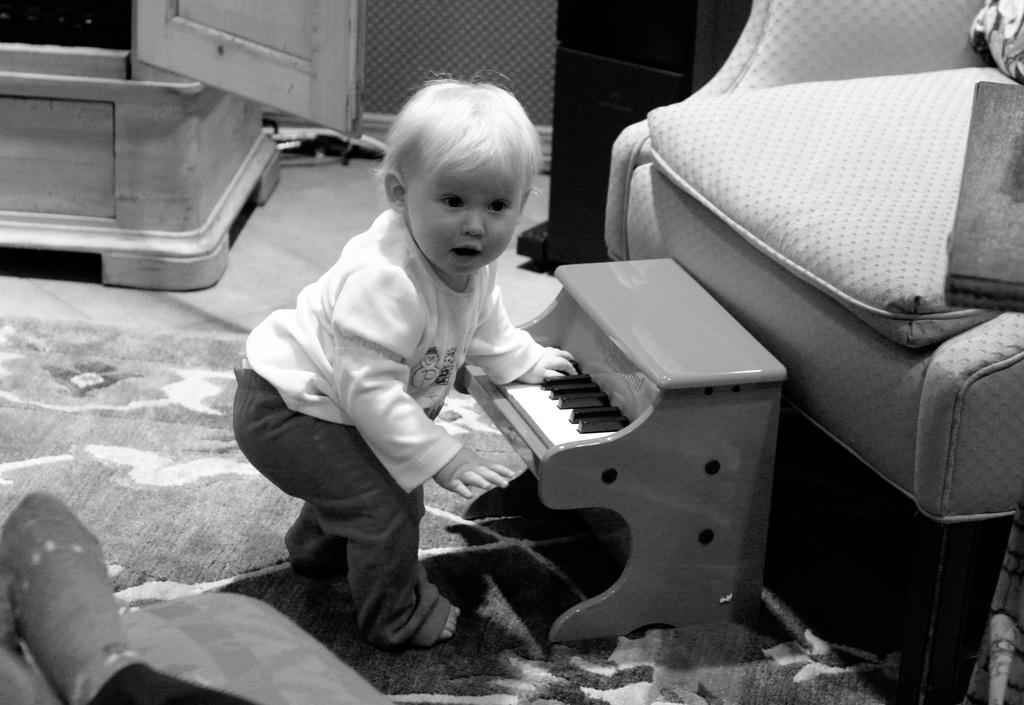What is the main subject of the image? There is a baby in the image. What is the baby doing in the image? The baby is playing a piano. What piece of furniture is on the right side of the image? There is a sofa on the right side of the image. How many balls are visible on the floor in the image? There are no balls visible on the floor in the image. 